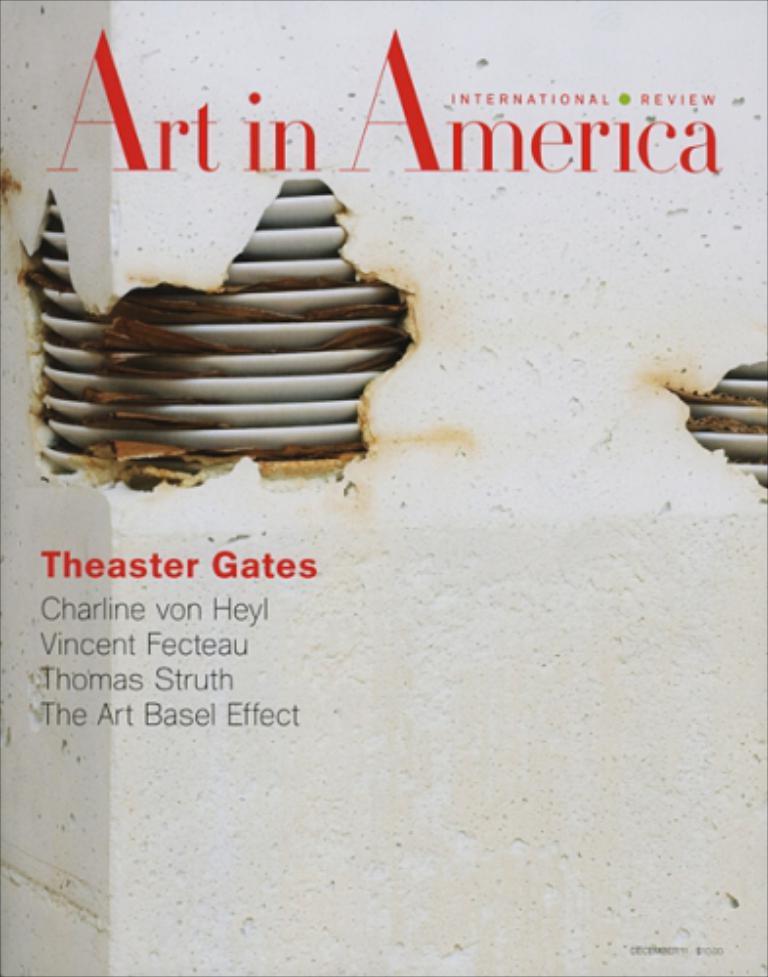What's the book title?
Your response must be concise. Art in america. 